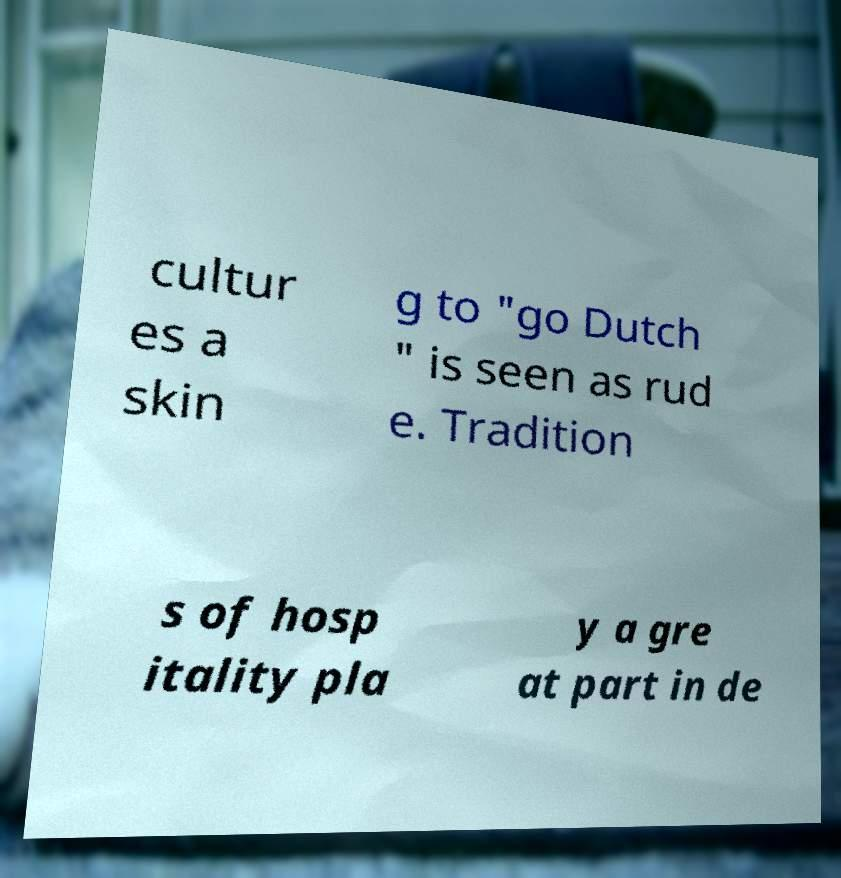I need the written content from this picture converted into text. Can you do that? cultur es a skin g to "go Dutch " is seen as rud e. Tradition s of hosp itality pla y a gre at part in de 